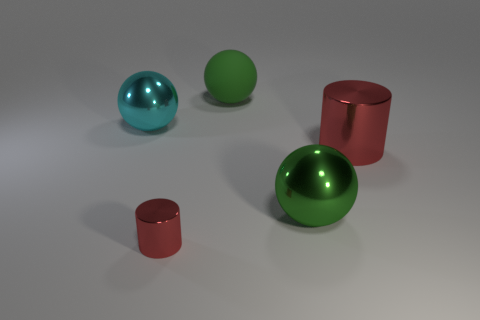Subtract 1 spheres. How many spheres are left? 2 Add 2 small red metal cylinders. How many objects exist? 7 Subtract all spheres. How many objects are left? 2 Add 2 big metallic things. How many big metallic things exist? 5 Subtract 0 blue cylinders. How many objects are left? 5 Subtract all blue shiny things. Subtract all big green things. How many objects are left? 3 Add 2 large red cylinders. How many large red cylinders are left? 3 